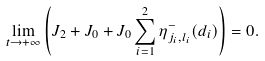<formula> <loc_0><loc_0><loc_500><loc_500>\lim _ { t \to + \infty } \left ( J _ { 2 } + J _ { 0 } + J _ { 0 } \sum _ { i = 1 } ^ { 2 } \eta _ { j _ { i } , l _ { i } } ^ { - } ( d _ { i } ) \right ) = 0 .</formula> 